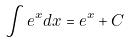<formula> <loc_0><loc_0><loc_500><loc_500>\int e ^ { x } d x = e ^ { x } + C</formula> 